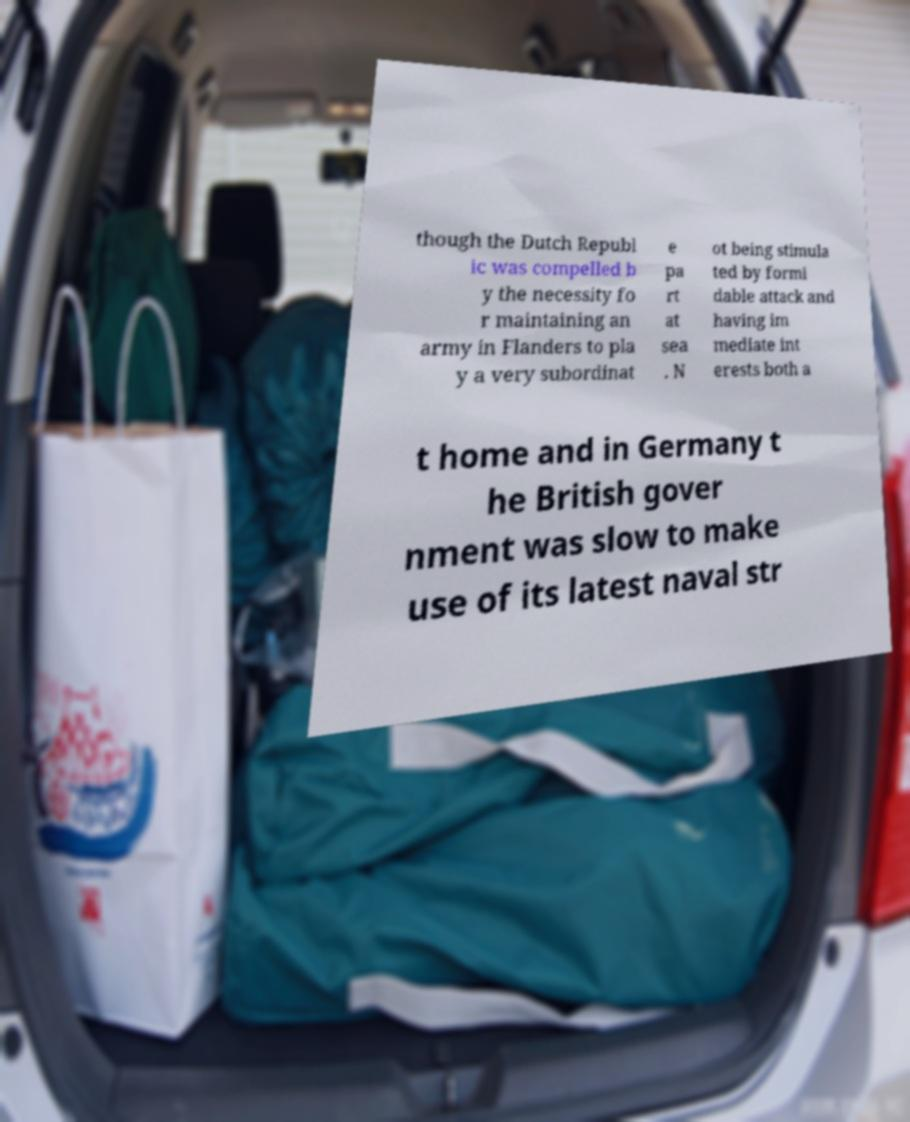There's text embedded in this image that I need extracted. Can you transcribe it verbatim? though the Dutch Republ ic was compelled b y the necessity fo r maintaining an army in Flanders to pla y a very subordinat e pa rt at sea . N ot being stimula ted by formi dable attack and having im mediate int erests both a t home and in Germany t he British gover nment was slow to make use of its latest naval str 